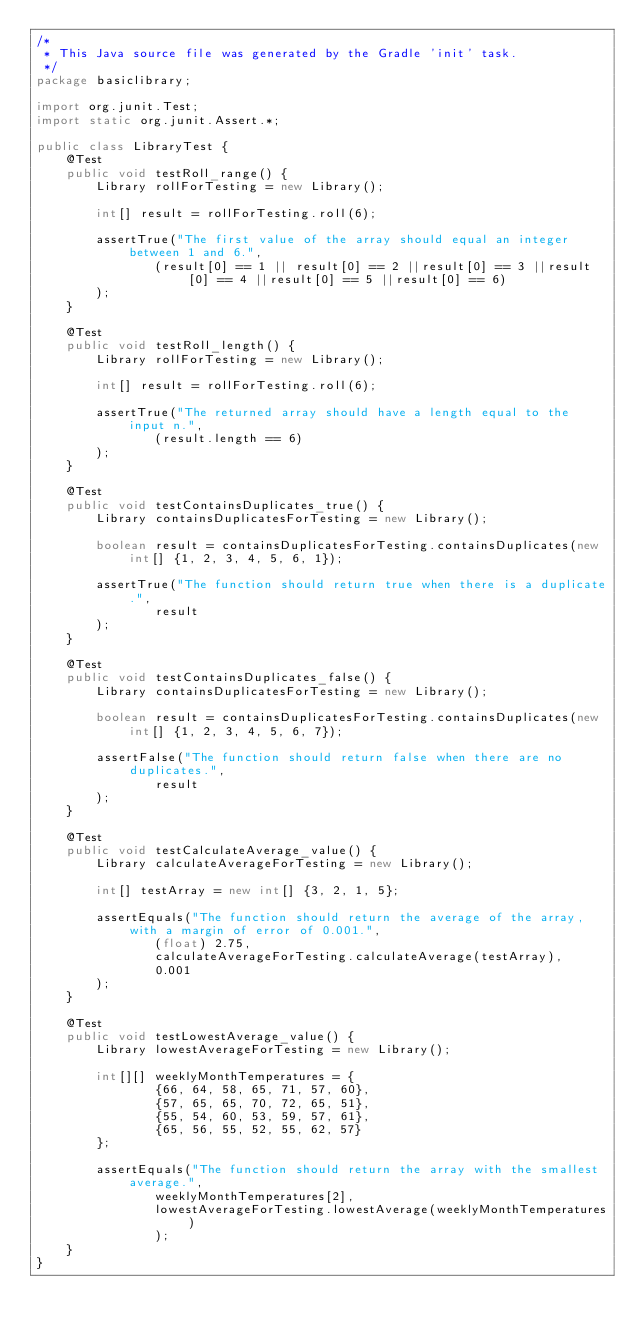<code> <loc_0><loc_0><loc_500><loc_500><_Java_>/*
 * This Java source file was generated by the Gradle 'init' task.
 */
package basiclibrary;

import org.junit.Test;
import static org.junit.Assert.*;

public class LibraryTest {
    @Test
    public void testRoll_range() {
        Library rollForTesting = new Library();

        int[] result = rollForTesting.roll(6);

        assertTrue("The first value of the array should equal an integer between 1 and 6.",
                (result[0] == 1 || result[0] == 2 ||result[0] == 3 ||result[0] == 4 ||result[0] == 5 ||result[0] == 6)
        );
    }

    @Test
    public void testRoll_length() {
        Library rollForTesting = new Library();

        int[] result = rollForTesting.roll(6);

        assertTrue("The returned array should have a length equal to the input n.",
                (result.length == 6)
        );
    }

    @Test
    public void testContainsDuplicates_true() {
        Library containsDuplicatesForTesting = new Library();

        boolean result = containsDuplicatesForTesting.containsDuplicates(new int[] {1, 2, 3, 4, 5, 6, 1});

        assertTrue("The function should return true when there is a duplicate.",
                result
        );
    }

    @Test
    public void testContainsDuplicates_false() {
        Library containsDuplicatesForTesting = new Library();

        boolean result = containsDuplicatesForTesting.containsDuplicates(new int[] {1, 2, 3, 4, 5, 6, 7});

        assertFalse("The function should return false when there are no duplicates.",
                result
        );
    }

    @Test
    public void testCalculateAverage_value() {
        Library calculateAverageForTesting = new Library();

        int[] testArray = new int[] {3, 2, 1, 5};

        assertEquals("The function should return the average of the array, with a margin of error of 0.001.",
                (float) 2.75,
                calculateAverageForTesting.calculateAverage(testArray),
                0.001
        );
    }

    @Test
    public void testLowestAverage_value() {
        Library lowestAverageForTesting = new Library();

        int[][] weeklyMonthTemperatures = {
                {66, 64, 58, 65, 71, 57, 60},
                {57, 65, 65, 70, 72, 65, 51},
                {55, 54, 60, 53, 59, 57, 61},
                {65, 56, 55, 52, 55, 62, 57}
        };

        assertEquals("The function should return the array with the smallest average.",
                weeklyMonthTemperatures[2],
                lowestAverageForTesting.lowestAverage(weeklyMonthTemperatures)
                );
    }
}
</code> 